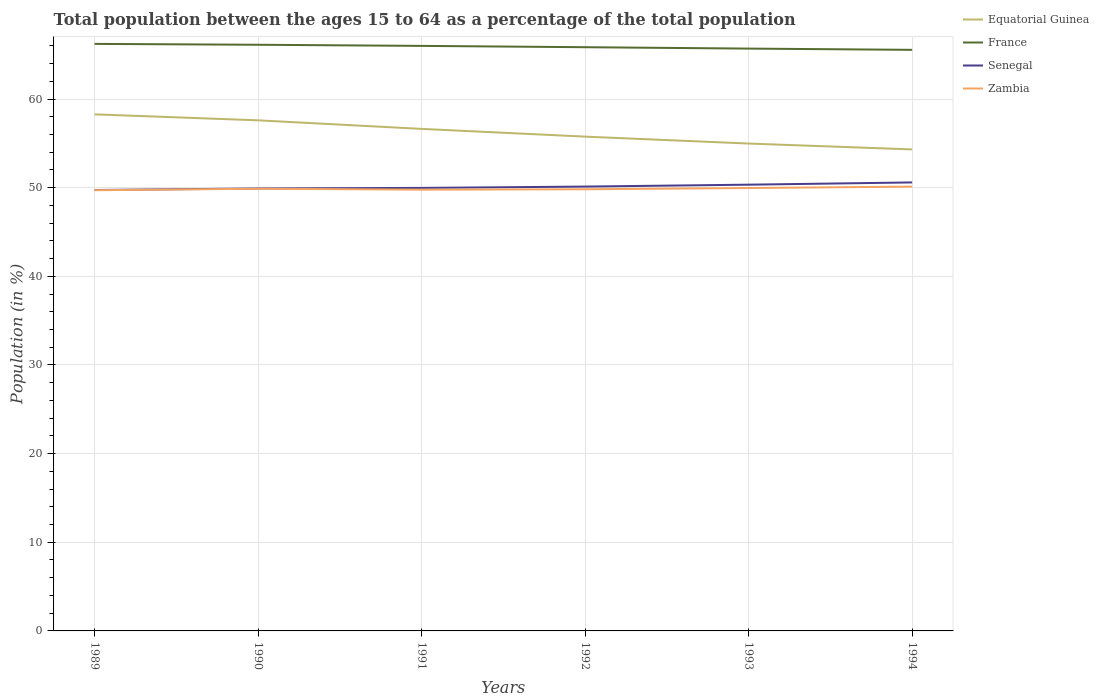Does the line corresponding to Senegal intersect with the line corresponding to Equatorial Guinea?
Ensure brevity in your answer.  No. Is the number of lines equal to the number of legend labels?
Provide a short and direct response. Yes. Across all years, what is the maximum percentage of the population ages 15 to 64 in France?
Your answer should be compact. 65.55. In which year was the percentage of the population ages 15 to 64 in Zambia maximum?
Keep it short and to the point. 1989. What is the total percentage of the population ages 15 to 64 in France in the graph?
Ensure brevity in your answer.  0.67. What is the difference between the highest and the second highest percentage of the population ages 15 to 64 in Zambia?
Your response must be concise. 0.41. What is the difference between the highest and the lowest percentage of the population ages 15 to 64 in Zambia?
Offer a very short reply. 3. How many years are there in the graph?
Give a very brief answer. 6. Are the values on the major ticks of Y-axis written in scientific E-notation?
Offer a very short reply. No. Where does the legend appear in the graph?
Your response must be concise. Top right. How many legend labels are there?
Give a very brief answer. 4. What is the title of the graph?
Offer a terse response. Total population between the ages 15 to 64 as a percentage of the total population. What is the Population (in %) in Equatorial Guinea in 1989?
Offer a terse response. 58.27. What is the Population (in %) in France in 1989?
Make the answer very short. 66.22. What is the Population (in %) in Senegal in 1989?
Your answer should be very brief. 49.74. What is the Population (in %) of Zambia in 1989?
Offer a very short reply. 49.71. What is the Population (in %) in Equatorial Guinea in 1990?
Offer a terse response. 57.6. What is the Population (in %) of France in 1990?
Give a very brief answer. 66.12. What is the Population (in %) in Senegal in 1990?
Give a very brief answer. 49.91. What is the Population (in %) in Zambia in 1990?
Give a very brief answer. 49.88. What is the Population (in %) of Equatorial Guinea in 1991?
Ensure brevity in your answer.  56.63. What is the Population (in %) of France in 1991?
Make the answer very short. 65.99. What is the Population (in %) of Senegal in 1991?
Offer a very short reply. 49.97. What is the Population (in %) of Zambia in 1991?
Give a very brief answer. 49.78. What is the Population (in %) of Equatorial Guinea in 1992?
Your answer should be compact. 55.76. What is the Population (in %) in France in 1992?
Your answer should be very brief. 65.84. What is the Population (in %) in Senegal in 1992?
Offer a terse response. 50.12. What is the Population (in %) in Zambia in 1992?
Ensure brevity in your answer.  49.82. What is the Population (in %) in Equatorial Guinea in 1993?
Offer a terse response. 54.98. What is the Population (in %) in France in 1993?
Offer a very short reply. 65.69. What is the Population (in %) of Senegal in 1993?
Offer a terse response. 50.34. What is the Population (in %) in Zambia in 1993?
Provide a succinct answer. 49.96. What is the Population (in %) of Equatorial Guinea in 1994?
Provide a short and direct response. 54.32. What is the Population (in %) of France in 1994?
Give a very brief answer. 65.55. What is the Population (in %) in Senegal in 1994?
Provide a short and direct response. 50.59. What is the Population (in %) in Zambia in 1994?
Make the answer very short. 50.12. Across all years, what is the maximum Population (in %) of Equatorial Guinea?
Give a very brief answer. 58.27. Across all years, what is the maximum Population (in %) in France?
Provide a short and direct response. 66.22. Across all years, what is the maximum Population (in %) in Senegal?
Your answer should be compact. 50.59. Across all years, what is the maximum Population (in %) of Zambia?
Provide a succinct answer. 50.12. Across all years, what is the minimum Population (in %) in Equatorial Guinea?
Provide a succinct answer. 54.32. Across all years, what is the minimum Population (in %) in France?
Your response must be concise. 65.55. Across all years, what is the minimum Population (in %) of Senegal?
Your response must be concise. 49.74. Across all years, what is the minimum Population (in %) in Zambia?
Ensure brevity in your answer.  49.71. What is the total Population (in %) of Equatorial Guinea in the graph?
Ensure brevity in your answer.  337.54. What is the total Population (in %) in France in the graph?
Keep it short and to the point. 395.4. What is the total Population (in %) in Senegal in the graph?
Provide a succinct answer. 300.67. What is the total Population (in %) of Zambia in the graph?
Your response must be concise. 299.26. What is the difference between the Population (in %) of Equatorial Guinea in 1989 and that in 1990?
Your answer should be very brief. 0.67. What is the difference between the Population (in %) in France in 1989 and that in 1990?
Provide a short and direct response. 0.1. What is the difference between the Population (in %) of Senegal in 1989 and that in 1990?
Make the answer very short. -0.17. What is the difference between the Population (in %) in Zambia in 1989 and that in 1990?
Provide a succinct answer. -0.17. What is the difference between the Population (in %) of Equatorial Guinea in 1989 and that in 1991?
Provide a short and direct response. 1.64. What is the difference between the Population (in %) of France in 1989 and that in 1991?
Offer a terse response. 0.23. What is the difference between the Population (in %) in Senegal in 1989 and that in 1991?
Your response must be concise. -0.24. What is the difference between the Population (in %) of Zambia in 1989 and that in 1991?
Ensure brevity in your answer.  -0.06. What is the difference between the Population (in %) in Equatorial Guinea in 1989 and that in 1992?
Your answer should be compact. 2.51. What is the difference between the Population (in %) of France in 1989 and that in 1992?
Keep it short and to the point. 0.37. What is the difference between the Population (in %) of Senegal in 1989 and that in 1992?
Provide a short and direct response. -0.39. What is the difference between the Population (in %) in Zambia in 1989 and that in 1992?
Your response must be concise. -0.11. What is the difference between the Population (in %) in Equatorial Guinea in 1989 and that in 1993?
Provide a succinct answer. 3.29. What is the difference between the Population (in %) of France in 1989 and that in 1993?
Make the answer very short. 0.53. What is the difference between the Population (in %) in Senegal in 1989 and that in 1993?
Your answer should be compact. -0.6. What is the difference between the Population (in %) in Zambia in 1989 and that in 1993?
Your response must be concise. -0.25. What is the difference between the Population (in %) of Equatorial Guinea in 1989 and that in 1994?
Provide a short and direct response. 3.95. What is the difference between the Population (in %) in France in 1989 and that in 1994?
Keep it short and to the point. 0.67. What is the difference between the Population (in %) in Senegal in 1989 and that in 1994?
Your answer should be compact. -0.85. What is the difference between the Population (in %) of Zambia in 1989 and that in 1994?
Give a very brief answer. -0.41. What is the difference between the Population (in %) in Equatorial Guinea in 1990 and that in 1991?
Offer a very short reply. 0.97. What is the difference between the Population (in %) of France in 1990 and that in 1991?
Your response must be concise. 0.13. What is the difference between the Population (in %) of Senegal in 1990 and that in 1991?
Provide a succinct answer. -0.06. What is the difference between the Population (in %) in Zambia in 1990 and that in 1991?
Offer a very short reply. 0.1. What is the difference between the Population (in %) in Equatorial Guinea in 1990 and that in 1992?
Keep it short and to the point. 1.84. What is the difference between the Population (in %) in France in 1990 and that in 1992?
Your answer should be compact. 0.27. What is the difference between the Population (in %) in Senegal in 1990 and that in 1992?
Keep it short and to the point. -0.22. What is the difference between the Population (in %) in Zambia in 1990 and that in 1992?
Your answer should be very brief. 0.06. What is the difference between the Population (in %) in Equatorial Guinea in 1990 and that in 1993?
Your answer should be compact. 2.62. What is the difference between the Population (in %) of France in 1990 and that in 1993?
Your answer should be compact. 0.43. What is the difference between the Population (in %) of Senegal in 1990 and that in 1993?
Your answer should be compact. -0.43. What is the difference between the Population (in %) in Zambia in 1990 and that in 1993?
Keep it short and to the point. -0.08. What is the difference between the Population (in %) of Equatorial Guinea in 1990 and that in 1994?
Your answer should be very brief. 3.28. What is the difference between the Population (in %) of France in 1990 and that in 1994?
Offer a very short reply. 0.57. What is the difference between the Population (in %) in Senegal in 1990 and that in 1994?
Offer a very short reply. -0.68. What is the difference between the Population (in %) of Zambia in 1990 and that in 1994?
Your response must be concise. -0.24. What is the difference between the Population (in %) of Equatorial Guinea in 1991 and that in 1992?
Provide a succinct answer. 0.87. What is the difference between the Population (in %) in France in 1991 and that in 1992?
Provide a succinct answer. 0.15. What is the difference between the Population (in %) of Senegal in 1991 and that in 1992?
Give a very brief answer. -0.15. What is the difference between the Population (in %) in Zambia in 1991 and that in 1992?
Provide a succinct answer. -0.04. What is the difference between the Population (in %) in Equatorial Guinea in 1991 and that in 1993?
Offer a terse response. 1.65. What is the difference between the Population (in %) in France in 1991 and that in 1993?
Offer a terse response. 0.3. What is the difference between the Population (in %) in Senegal in 1991 and that in 1993?
Your answer should be very brief. -0.36. What is the difference between the Population (in %) in Zambia in 1991 and that in 1993?
Provide a succinct answer. -0.18. What is the difference between the Population (in %) in Equatorial Guinea in 1991 and that in 1994?
Ensure brevity in your answer.  2.31. What is the difference between the Population (in %) in France in 1991 and that in 1994?
Make the answer very short. 0.44. What is the difference between the Population (in %) in Senegal in 1991 and that in 1994?
Make the answer very short. -0.62. What is the difference between the Population (in %) of Zambia in 1991 and that in 1994?
Ensure brevity in your answer.  -0.34. What is the difference between the Population (in %) of Equatorial Guinea in 1992 and that in 1993?
Offer a very short reply. 0.78. What is the difference between the Population (in %) in France in 1992 and that in 1993?
Your answer should be compact. 0.16. What is the difference between the Population (in %) of Senegal in 1992 and that in 1993?
Keep it short and to the point. -0.21. What is the difference between the Population (in %) in Zambia in 1992 and that in 1993?
Provide a short and direct response. -0.14. What is the difference between the Population (in %) of Equatorial Guinea in 1992 and that in 1994?
Provide a short and direct response. 1.44. What is the difference between the Population (in %) in France in 1992 and that in 1994?
Your response must be concise. 0.3. What is the difference between the Population (in %) in Senegal in 1992 and that in 1994?
Provide a short and direct response. -0.47. What is the difference between the Population (in %) in Zambia in 1992 and that in 1994?
Offer a terse response. -0.3. What is the difference between the Population (in %) in Equatorial Guinea in 1993 and that in 1994?
Provide a short and direct response. 0.66. What is the difference between the Population (in %) in France in 1993 and that in 1994?
Your answer should be compact. 0.14. What is the difference between the Population (in %) of Senegal in 1993 and that in 1994?
Give a very brief answer. -0.25. What is the difference between the Population (in %) in Zambia in 1993 and that in 1994?
Give a very brief answer. -0.16. What is the difference between the Population (in %) in Equatorial Guinea in 1989 and the Population (in %) in France in 1990?
Make the answer very short. -7.85. What is the difference between the Population (in %) in Equatorial Guinea in 1989 and the Population (in %) in Senegal in 1990?
Your answer should be very brief. 8.36. What is the difference between the Population (in %) of Equatorial Guinea in 1989 and the Population (in %) of Zambia in 1990?
Ensure brevity in your answer.  8.39. What is the difference between the Population (in %) in France in 1989 and the Population (in %) in Senegal in 1990?
Provide a succinct answer. 16.31. What is the difference between the Population (in %) of France in 1989 and the Population (in %) of Zambia in 1990?
Ensure brevity in your answer.  16.34. What is the difference between the Population (in %) in Senegal in 1989 and the Population (in %) in Zambia in 1990?
Your response must be concise. -0.14. What is the difference between the Population (in %) in Equatorial Guinea in 1989 and the Population (in %) in France in 1991?
Ensure brevity in your answer.  -7.72. What is the difference between the Population (in %) of Equatorial Guinea in 1989 and the Population (in %) of Senegal in 1991?
Provide a short and direct response. 8.3. What is the difference between the Population (in %) in Equatorial Guinea in 1989 and the Population (in %) in Zambia in 1991?
Give a very brief answer. 8.49. What is the difference between the Population (in %) of France in 1989 and the Population (in %) of Senegal in 1991?
Your response must be concise. 16.25. What is the difference between the Population (in %) in France in 1989 and the Population (in %) in Zambia in 1991?
Ensure brevity in your answer.  16.44. What is the difference between the Population (in %) of Senegal in 1989 and the Population (in %) of Zambia in 1991?
Offer a very short reply. -0.04. What is the difference between the Population (in %) in Equatorial Guinea in 1989 and the Population (in %) in France in 1992?
Offer a very short reply. -7.57. What is the difference between the Population (in %) in Equatorial Guinea in 1989 and the Population (in %) in Senegal in 1992?
Ensure brevity in your answer.  8.15. What is the difference between the Population (in %) in Equatorial Guinea in 1989 and the Population (in %) in Zambia in 1992?
Offer a very short reply. 8.45. What is the difference between the Population (in %) in France in 1989 and the Population (in %) in Senegal in 1992?
Keep it short and to the point. 16.09. What is the difference between the Population (in %) in France in 1989 and the Population (in %) in Zambia in 1992?
Ensure brevity in your answer.  16.4. What is the difference between the Population (in %) in Senegal in 1989 and the Population (in %) in Zambia in 1992?
Provide a succinct answer. -0.08. What is the difference between the Population (in %) in Equatorial Guinea in 1989 and the Population (in %) in France in 1993?
Offer a very short reply. -7.42. What is the difference between the Population (in %) in Equatorial Guinea in 1989 and the Population (in %) in Senegal in 1993?
Provide a succinct answer. 7.93. What is the difference between the Population (in %) of Equatorial Guinea in 1989 and the Population (in %) of Zambia in 1993?
Provide a short and direct response. 8.31. What is the difference between the Population (in %) in France in 1989 and the Population (in %) in Senegal in 1993?
Provide a short and direct response. 15.88. What is the difference between the Population (in %) of France in 1989 and the Population (in %) of Zambia in 1993?
Your answer should be compact. 16.26. What is the difference between the Population (in %) in Senegal in 1989 and the Population (in %) in Zambia in 1993?
Provide a short and direct response. -0.22. What is the difference between the Population (in %) in Equatorial Guinea in 1989 and the Population (in %) in France in 1994?
Offer a very short reply. -7.28. What is the difference between the Population (in %) of Equatorial Guinea in 1989 and the Population (in %) of Senegal in 1994?
Offer a very short reply. 7.68. What is the difference between the Population (in %) of Equatorial Guinea in 1989 and the Population (in %) of Zambia in 1994?
Offer a very short reply. 8.15. What is the difference between the Population (in %) in France in 1989 and the Population (in %) in Senegal in 1994?
Provide a short and direct response. 15.63. What is the difference between the Population (in %) of France in 1989 and the Population (in %) of Zambia in 1994?
Your answer should be very brief. 16.1. What is the difference between the Population (in %) in Senegal in 1989 and the Population (in %) in Zambia in 1994?
Give a very brief answer. -0.38. What is the difference between the Population (in %) in Equatorial Guinea in 1990 and the Population (in %) in France in 1991?
Provide a succinct answer. -8.4. What is the difference between the Population (in %) in Equatorial Guinea in 1990 and the Population (in %) in Senegal in 1991?
Your response must be concise. 7.62. What is the difference between the Population (in %) of Equatorial Guinea in 1990 and the Population (in %) of Zambia in 1991?
Give a very brief answer. 7.82. What is the difference between the Population (in %) of France in 1990 and the Population (in %) of Senegal in 1991?
Provide a short and direct response. 16.15. What is the difference between the Population (in %) in France in 1990 and the Population (in %) in Zambia in 1991?
Your answer should be compact. 16.34. What is the difference between the Population (in %) in Senegal in 1990 and the Population (in %) in Zambia in 1991?
Your response must be concise. 0.13. What is the difference between the Population (in %) in Equatorial Guinea in 1990 and the Population (in %) in France in 1992?
Offer a terse response. -8.25. What is the difference between the Population (in %) of Equatorial Guinea in 1990 and the Population (in %) of Senegal in 1992?
Provide a succinct answer. 7.47. What is the difference between the Population (in %) in Equatorial Guinea in 1990 and the Population (in %) in Zambia in 1992?
Offer a terse response. 7.78. What is the difference between the Population (in %) in France in 1990 and the Population (in %) in Senegal in 1992?
Your answer should be compact. 16. What is the difference between the Population (in %) in France in 1990 and the Population (in %) in Zambia in 1992?
Give a very brief answer. 16.3. What is the difference between the Population (in %) in Senegal in 1990 and the Population (in %) in Zambia in 1992?
Offer a terse response. 0.09. What is the difference between the Population (in %) in Equatorial Guinea in 1990 and the Population (in %) in France in 1993?
Give a very brief answer. -8.09. What is the difference between the Population (in %) of Equatorial Guinea in 1990 and the Population (in %) of Senegal in 1993?
Your response must be concise. 7.26. What is the difference between the Population (in %) in Equatorial Guinea in 1990 and the Population (in %) in Zambia in 1993?
Your answer should be compact. 7.64. What is the difference between the Population (in %) of France in 1990 and the Population (in %) of Senegal in 1993?
Offer a very short reply. 15.78. What is the difference between the Population (in %) of France in 1990 and the Population (in %) of Zambia in 1993?
Your response must be concise. 16.16. What is the difference between the Population (in %) in Senegal in 1990 and the Population (in %) in Zambia in 1993?
Give a very brief answer. -0.05. What is the difference between the Population (in %) of Equatorial Guinea in 1990 and the Population (in %) of France in 1994?
Your response must be concise. -7.95. What is the difference between the Population (in %) of Equatorial Guinea in 1990 and the Population (in %) of Senegal in 1994?
Provide a succinct answer. 7.01. What is the difference between the Population (in %) of Equatorial Guinea in 1990 and the Population (in %) of Zambia in 1994?
Your answer should be compact. 7.48. What is the difference between the Population (in %) in France in 1990 and the Population (in %) in Senegal in 1994?
Offer a terse response. 15.53. What is the difference between the Population (in %) in France in 1990 and the Population (in %) in Zambia in 1994?
Your answer should be very brief. 16. What is the difference between the Population (in %) of Senegal in 1990 and the Population (in %) of Zambia in 1994?
Provide a succinct answer. -0.21. What is the difference between the Population (in %) in Equatorial Guinea in 1991 and the Population (in %) in France in 1992?
Provide a short and direct response. -9.21. What is the difference between the Population (in %) in Equatorial Guinea in 1991 and the Population (in %) in Senegal in 1992?
Your response must be concise. 6.51. What is the difference between the Population (in %) in Equatorial Guinea in 1991 and the Population (in %) in Zambia in 1992?
Your answer should be very brief. 6.81. What is the difference between the Population (in %) in France in 1991 and the Population (in %) in Senegal in 1992?
Offer a very short reply. 15.87. What is the difference between the Population (in %) of France in 1991 and the Population (in %) of Zambia in 1992?
Make the answer very short. 16.17. What is the difference between the Population (in %) of Senegal in 1991 and the Population (in %) of Zambia in 1992?
Make the answer very short. 0.15. What is the difference between the Population (in %) in Equatorial Guinea in 1991 and the Population (in %) in France in 1993?
Provide a succinct answer. -9.06. What is the difference between the Population (in %) of Equatorial Guinea in 1991 and the Population (in %) of Senegal in 1993?
Keep it short and to the point. 6.29. What is the difference between the Population (in %) in Equatorial Guinea in 1991 and the Population (in %) in Zambia in 1993?
Keep it short and to the point. 6.67. What is the difference between the Population (in %) in France in 1991 and the Population (in %) in Senegal in 1993?
Provide a succinct answer. 15.65. What is the difference between the Population (in %) in France in 1991 and the Population (in %) in Zambia in 1993?
Your response must be concise. 16.03. What is the difference between the Population (in %) in Senegal in 1991 and the Population (in %) in Zambia in 1993?
Keep it short and to the point. 0.01. What is the difference between the Population (in %) in Equatorial Guinea in 1991 and the Population (in %) in France in 1994?
Your response must be concise. -8.92. What is the difference between the Population (in %) in Equatorial Guinea in 1991 and the Population (in %) in Senegal in 1994?
Your answer should be very brief. 6.04. What is the difference between the Population (in %) of Equatorial Guinea in 1991 and the Population (in %) of Zambia in 1994?
Offer a terse response. 6.51. What is the difference between the Population (in %) of France in 1991 and the Population (in %) of Senegal in 1994?
Offer a very short reply. 15.4. What is the difference between the Population (in %) of France in 1991 and the Population (in %) of Zambia in 1994?
Your answer should be very brief. 15.87. What is the difference between the Population (in %) in Senegal in 1991 and the Population (in %) in Zambia in 1994?
Your answer should be compact. -0.15. What is the difference between the Population (in %) of Equatorial Guinea in 1992 and the Population (in %) of France in 1993?
Provide a short and direct response. -9.93. What is the difference between the Population (in %) in Equatorial Guinea in 1992 and the Population (in %) in Senegal in 1993?
Give a very brief answer. 5.42. What is the difference between the Population (in %) in Equatorial Guinea in 1992 and the Population (in %) in Zambia in 1993?
Ensure brevity in your answer.  5.8. What is the difference between the Population (in %) in France in 1992 and the Population (in %) in Senegal in 1993?
Your response must be concise. 15.51. What is the difference between the Population (in %) of France in 1992 and the Population (in %) of Zambia in 1993?
Your response must be concise. 15.89. What is the difference between the Population (in %) in Senegal in 1992 and the Population (in %) in Zambia in 1993?
Give a very brief answer. 0.16. What is the difference between the Population (in %) of Equatorial Guinea in 1992 and the Population (in %) of France in 1994?
Your response must be concise. -9.79. What is the difference between the Population (in %) in Equatorial Guinea in 1992 and the Population (in %) in Senegal in 1994?
Your response must be concise. 5.17. What is the difference between the Population (in %) in Equatorial Guinea in 1992 and the Population (in %) in Zambia in 1994?
Your response must be concise. 5.64. What is the difference between the Population (in %) of France in 1992 and the Population (in %) of Senegal in 1994?
Provide a succinct answer. 15.25. What is the difference between the Population (in %) in France in 1992 and the Population (in %) in Zambia in 1994?
Offer a terse response. 15.72. What is the difference between the Population (in %) in Senegal in 1992 and the Population (in %) in Zambia in 1994?
Your answer should be compact. 0. What is the difference between the Population (in %) of Equatorial Guinea in 1993 and the Population (in %) of France in 1994?
Ensure brevity in your answer.  -10.57. What is the difference between the Population (in %) of Equatorial Guinea in 1993 and the Population (in %) of Senegal in 1994?
Keep it short and to the point. 4.39. What is the difference between the Population (in %) in Equatorial Guinea in 1993 and the Population (in %) in Zambia in 1994?
Keep it short and to the point. 4.86. What is the difference between the Population (in %) in France in 1993 and the Population (in %) in Senegal in 1994?
Provide a short and direct response. 15.1. What is the difference between the Population (in %) of France in 1993 and the Population (in %) of Zambia in 1994?
Provide a succinct answer. 15.57. What is the difference between the Population (in %) in Senegal in 1993 and the Population (in %) in Zambia in 1994?
Your answer should be compact. 0.22. What is the average Population (in %) of Equatorial Guinea per year?
Ensure brevity in your answer.  56.26. What is the average Population (in %) of France per year?
Give a very brief answer. 65.9. What is the average Population (in %) in Senegal per year?
Ensure brevity in your answer.  50.11. What is the average Population (in %) of Zambia per year?
Keep it short and to the point. 49.88. In the year 1989, what is the difference between the Population (in %) in Equatorial Guinea and Population (in %) in France?
Offer a very short reply. -7.95. In the year 1989, what is the difference between the Population (in %) in Equatorial Guinea and Population (in %) in Senegal?
Your answer should be very brief. 8.53. In the year 1989, what is the difference between the Population (in %) of Equatorial Guinea and Population (in %) of Zambia?
Give a very brief answer. 8.56. In the year 1989, what is the difference between the Population (in %) in France and Population (in %) in Senegal?
Your response must be concise. 16.48. In the year 1989, what is the difference between the Population (in %) in France and Population (in %) in Zambia?
Make the answer very short. 16.51. In the year 1989, what is the difference between the Population (in %) of Senegal and Population (in %) of Zambia?
Ensure brevity in your answer.  0.03. In the year 1990, what is the difference between the Population (in %) in Equatorial Guinea and Population (in %) in France?
Your answer should be compact. -8.52. In the year 1990, what is the difference between the Population (in %) of Equatorial Guinea and Population (in %) of Senegal?
Give a very brief answer. 7.69. In the year 1990, what is the difference between the Population (in %) of Equatorial Guinea and Population (in %) of Zambia?
Offer a very short reply. 7.72. In the year 1990, what is the difference between the Population (in %) of France and Population (in %) of Senegal?
Provide a succinct answer. 16.21. In the year 1990, what is the difference between the Population (in %) of France and Population (in %) of Zambia?
Offer a very short reply. 16.24. In the year 1990, what is the difference between the Population (in %) in Senegal and Population (in %) in Zambia?
Keep it short and to the point. 0.03. In the year 1991, what is the difference between the Population (in %) in Equatorial Guinea and Population (in %) in France?
Provide a short and direct response. -9.36. In the year 1991, what is the difference between the Population (in %) in Equatorial Guinea and Population (in %) in Senegal?
Ensure brevity in your answer.  6.66. In the year 1991, what is the difference between the Population (in %) in Equatorial Guinea and Population (in %) in Zambia?
Offer a very short reply. 6.85. In the year 1991, what is the difference between the Population (in %) of France and Population (in %) of Senegal?
Provide a short and direct response. 16.02. In the year 1991, what is the difference between the Population (in %) in France and Population (in %) in Zambia?
Your answer should be compact. 16.22. In the year 1991, what is the difference between the Population (in %) in Senegal and Population (in %) in Zambia?
Provide a short and direct response. 0.2. In the year 1992, what is the difference between the Population (in %) in Equatorial Guinea and Population (in %) in France?
Keep it short and to the point. -10.09. In the year 1992, what is the difference between the Population (in %) of Equatorial Guinea and Population (in %) of Senegal?
Keep it short and to the point. 5.63. In the year 1992, what is the difference between the Population (in %) of Equatorial Guinea and Population (in %) of Zambia?
Keep it short and to the point. 5.94. In the year 1992, what is the difference between the Population (in %) of France and Population (in %) of Senegal?
Provide a short and direct response. 15.72. In the year 1992, what is the difference between the Population (in %) in France and Population (in %) in Zambia?
Make the answer very short. 16.02. In the year 1992, what is the difference between the Population (in %) of Senegal and Population (in %) of Zambia?
Provide a short and direct response. 0.3. In the year 1993, what is the difference between the Population (in %) of Equatorial Guinea and Population (in %) of France?
Give a very brief answer. -10.71. In the year 1993, what is the difference between the Population (in %) in Equatorial Guinea and Population (in %) in Senegal?
Provide a succinct answer. 4.64. In the year 1993, what is the difference between the Population (in %) in Equatorial Guinea and Population (in %) in Zambia?
Your answer should be compact. 5.02. In the year 1993, what is the difference between the Population (in %) of France and Population (in %) of Senegal?
Your answer should be compact. 15.35. In the year 1993, what is the difference between the Population (in %) of France and Population (in %) of Zambia?
Offer a very short reply. 15.73. In the year 1993, what is the difference between the Population (in %) in Senegal and Population (in %) in Zambia?
Make the answer very short. 0.38. In the year 1994, what is the difference between the Population (in %) in Equatorial Guinea and Population (in %) in France?
Offer a very short reply. -11.23. In the year 1994, what is the difference between the Population (in %) in Equatorial Guinea and Population (in %) in Senegal?
Ensure brevity in your answer.  3.73. In the year 1994, what is the difference between the Population (in %) in Equatorial Guinea and Population (in %) in Zambia?
Your answer should be very brief. 4.2. In the year 1994, what is the difference between the Population (in %) in France and Population (in %) in Senegal?
Offer a very short reply. 14.96. In the year 1994, what is the difference between the Population (in %) in France and Population (in %) in Zambia?
Offer a very short reply. 15.43. In the year 1994, what is the difference between the Population (in %) of Senegal and Population (in %) of Zambia?
Keep it short and to the point. 0.47. What is the ratio of the Population (in %) of Equatorial Guinea in 1989 to that in 1990?
Give a very brief answer. 1.01. What is the ratio of the Population (in %) of Equatorial Guinea in 1989 to that in 1991?
Your response must be concise. 1.03. What is the ratio of the Population (in %) in France in 1989 to that in 1991?
Give a very brief answer. 1. What is the ratio of the Population (in %) in Zambia in 1989 to that in 1991?
Keep it short and to the point. 1. What is the ratio of the Population (in %) in Equatorial Guinea in 1989 to that in 1992?
Your response must be concise. 1.05. What is the ratio of the Population (in %) in Equatorial Guinea in 1989 to that in 1993?
Keep it short and to the point. 1.06. What is the ratio of the Population (in %) in France in 1989 to that in 1993?
Your answer should be compact. 1.01. What is the ratio of the Population (in %) in Senegal in 1989 to that in 1993?
Your response must be concise. 0.99. What is the ratio of the Population (in %) in Equatorial Guinea in 1989 to that in 1994?
Your answer should be compact. 1.07. What is the ratio of the Population (in %) in France in 1989 to that in 1994?
Ensure brevity in your answer.  1.01. What is the ratio of the Population (in %) of Senegal in 1989 to that in 1994?
Offer a very short reply. 0.98. What is the ratio of the Population (in %) in Equatorial Guinea in 1990 to that in 1991?
Provide a short and direct response. 1.02. What is the ratio of the Population (in %) in France in 1990 to that in 1991?
Keep it short and to the point. 1. What is the ratio of the Population (in %) of Senegal in 1990 to that in 1991?
Offer a terse response. 1. What is the ratio of the Population (in %) in Zambia in 1990 to that in 1991?
Provide a succinct answer. 1. What is the ratio of the Population (in %) of Equatorial Guinea in 1990 to that in 1992?
Your answer should be very brief. 1.03. What is the ratio of the Population (in %) in France in 1990 to that in 1992?
Give a very brief answer. 1. What is the ratio of the Population (in %) in Senegal in 1990 to that in 1992?
Provide a succinct answer. 1. What is the ratio of the Population (in %) in Zambia in 1990 to that in 1992?
Give a very brief answer. 1. What is the ratio of the Population (in %) of Equatorial Guinea in 1990 to that in 1993?
Give a very brief answer. 1.05. What is the ratio of the Population (in %) of France in 1990 to that in 1993?
Offer a terse response. 1.01. What is the ratio of the Population (in %) of Equatorial Guinea in 1990 to that in 1994?
Offer a terse response. 1.06. What is the ratio of the Population (in %) in France in 1990 to that in 1994?
Your answer should be very brief. 1.01. What is the ratio of the Population (in %) in Senegal in 1990 to that in 1994?
Offer a very short reply. 0.99. What is the ratio of the Population (in %) in Zambia in 1990 to that in 1994?
Provide a succinct answer. 1. What is the ratio of the Population (in %) in Equatorial Guinea in 1991 to that in 1992?
Keep it short and to the point. 1.02. What is the ratio of the Population (in %) in France in 1991 to that in 1992?
Offer a very short reply. 1. What is the ratio of the Population (in %) of Zambia in 1991 to that in 1992?
Provide a succinct answer. 1. What is the ratio of the Population (in %) of Equatorial Guinea in 1991 to that in 1993?
Your answer should be very brief. 1.03. What is the ratio of the Population (in %) in Equatorial Guinea in 1991 to that in 1994?
Offer a terse response. 1.04. What is the ratio of the Population (in %) in France in 1991 to that in 1994?
Your response must be concise. 1.01. What is the ratio of the Population (in %) in Senegal in 1991 to that in 1994?
Your answer should be very brief. 0.99. What is the ratio of the Population (in %) in Zambia in 1991 to that in 1994?
Keep it short and to the point. 0.99. What is the ratio of the Population (in %) of Equatorial Guinea in 1992 to that in 1993?
Your answer should be compact. 1.01. What is the ratio of the Population (in %) of France in 1992 to that in 1993?
Your response must be concise. 1. What is the ratio of the Population (in %) in Senegal in 1992 to that in 1993?
Offer a very short reply. 1. What is the ratio of the Population (in %) of Zambia in 1992 to that in 1993?
Provide a succinct answer. 1. What is the ratio of the Population (in %) in Equatorial Guinea in 1992 to that in 1994?
Ensure brevity in your answer.  1.03. What is the ratio of the Population (in %) in Senegal in 1992 to that in 1994?
Give a very brief answer. 0.99. What is the ratio of the Population (in %) of Zambia in 1992 to that in 1994?
Your response must be concise. 0.99. What is the ratio of the Population (in %) of Equatorial Guinea in 1993 to that in 1994?
Offer a very short reply. 1.01. What is the difference between the highest and the second highest Population (in %) in Equatorial Guinea?
Offer a terse response. 0.67. What is the difference between the highest and the second highest Population (in %) of France?
Offer a terse response. 0.1. What is the difference between the highest and the second highest Population (in %) in Senegal?
Give a very brief answer. 0.25. What is the difference between the highest and the second highest Population (in %) in Zambia?
Give a very brief answer. 0.16. What is the difference between the highest and the lowest Population (in %) in Equatorial Guinea?
Offer a terse response. 3.95. What is the difference between the highest and the lowest Population (in %) of France?
Ensure brevity in your answer.  0.67. What is the difference between the highest and the lowest Population (in %) in Senegal?
Make the answer very short. 0.85. What is the difference between the highest and the lowest Population (in %) of Zambia?
Your answer should be very brief. 0.41. 